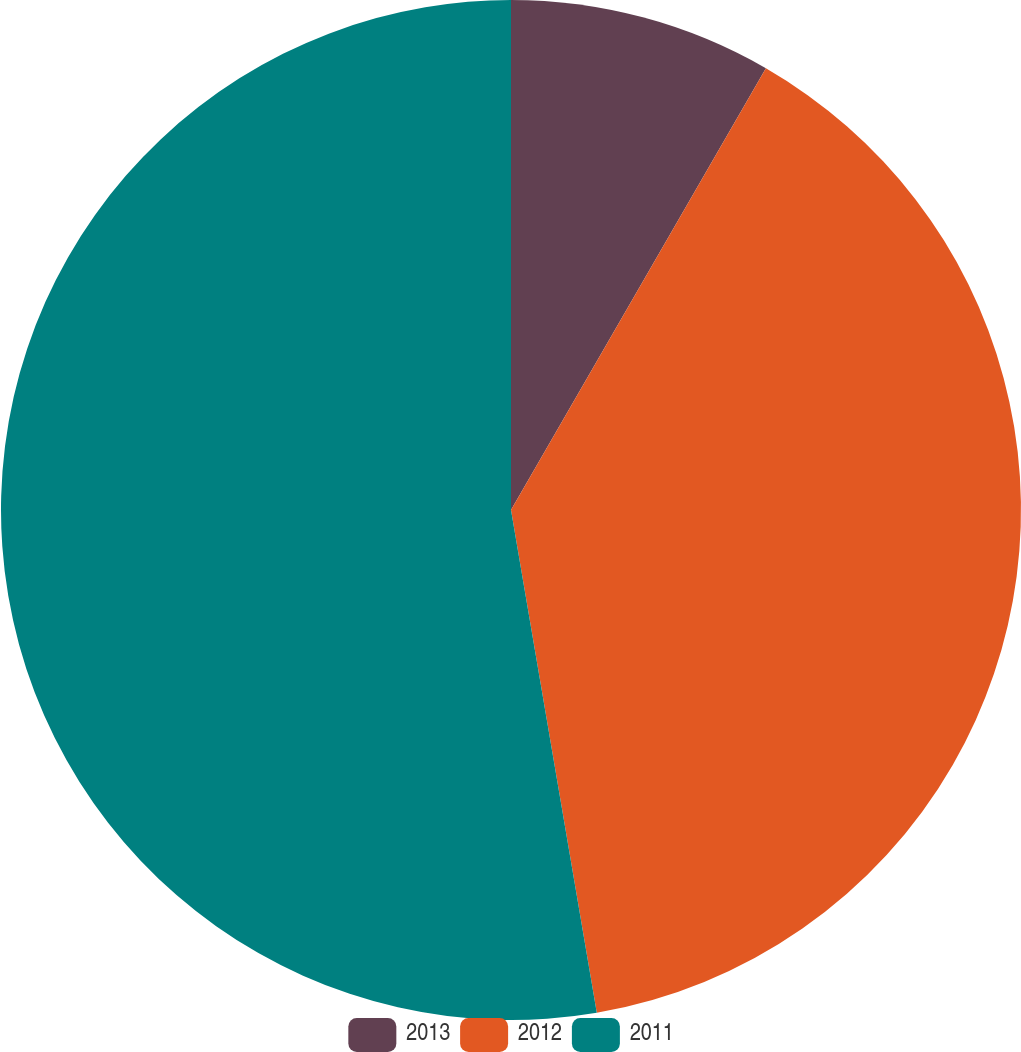Convert chart to OTSL. <chart><loc_0><loc_0><loc_500><loc_500><pie_chart><fcel>2013<fcel>2012<fcel>2011<nl><fcel>8.33%<fcel>38.98%<fcel>52.69%<nl></chart> 